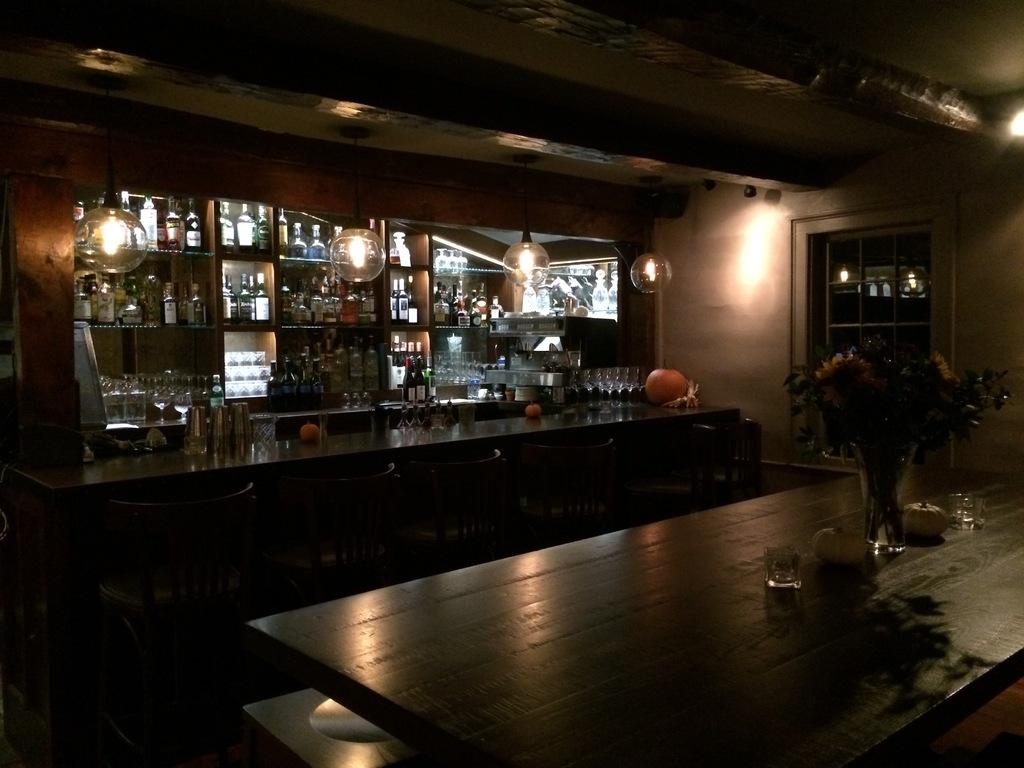What objects are on the racks in the image? There are bottles on the racks in the image. What type of decorative objects are present in the image? There are light balls in the image. What is contained in the glass in the image? There are flowers in a glass in the image. Where is the glass with flowers located in the image? The glass with flowers is on a table in the image. What type of wine is being served in the image? There is no wine present in the image; it features bottles, light balls, flowers in a glass, and a table. How are the light balls connected to the flowers in the image? The light balls and flowers are not connected in the image; they are separate objects. 